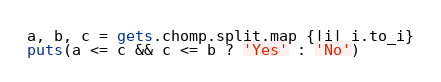Convert code to text. <code><loc_0><loc_0><loc_500><loc_500><_Ruby_>a, b, c = gets.chomp.split.map {|i| i.to_i}
puts(a <= c && c <= b ? 'Yes' : 'No')
</code> 